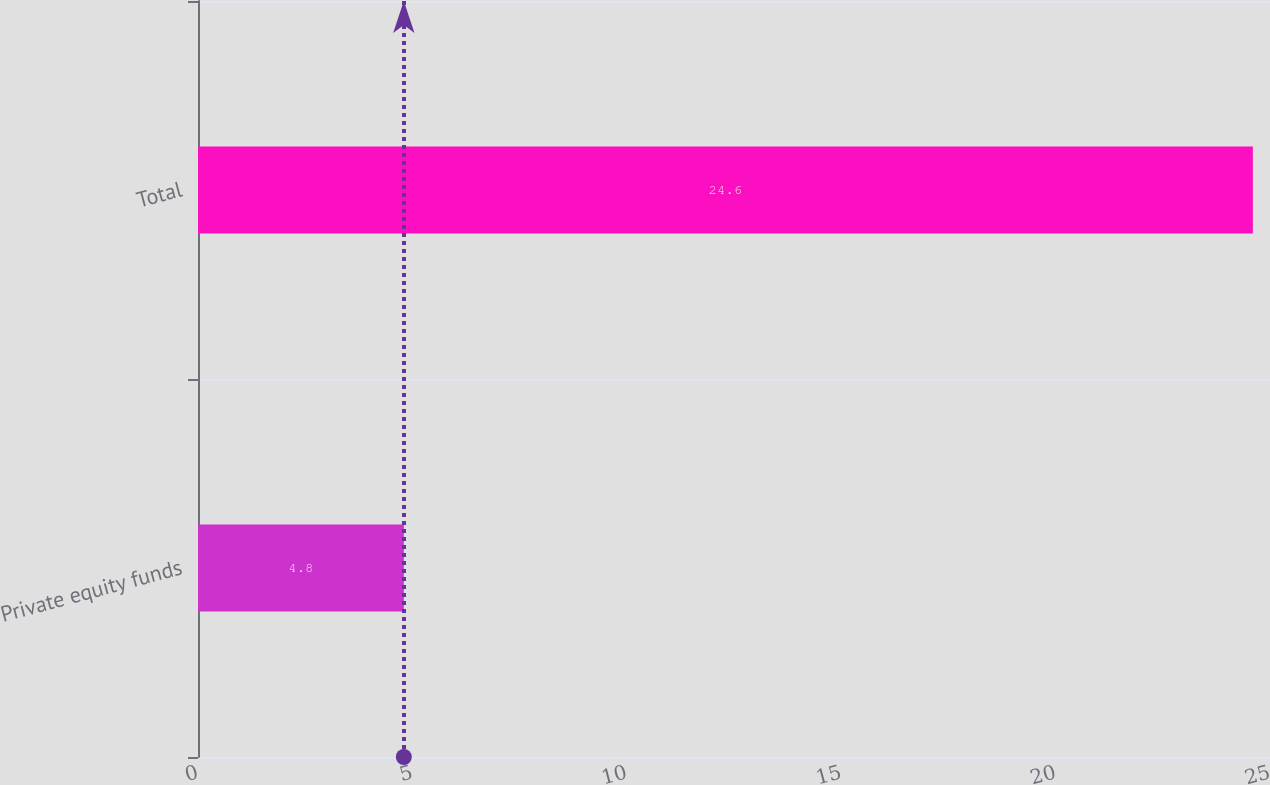Convert chart. <chart><loc_0><loc_0><loc_500><loc_500><bar_chart><fcel>Private equity funds<fcel>Total<nl><fcel>4.8<fcel>24.6<nl></chart> 